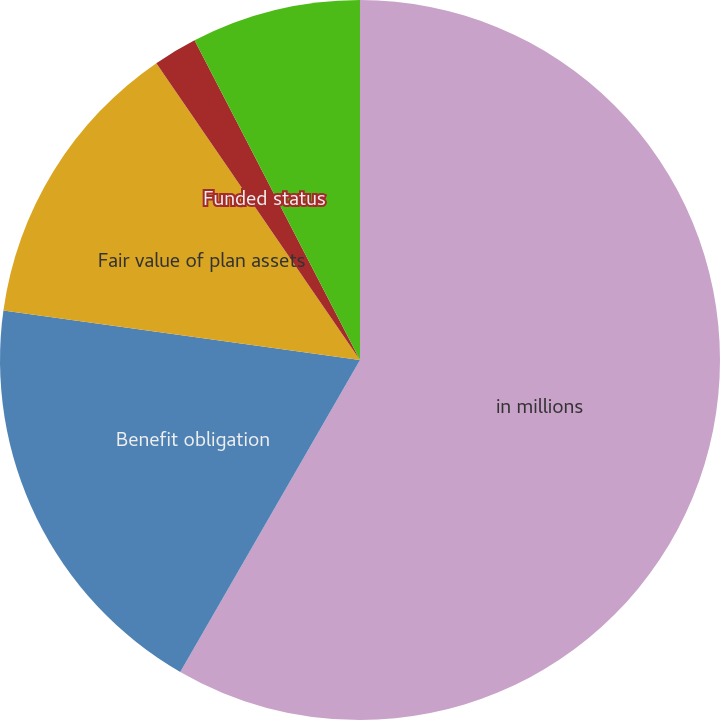Convert chart. <chart><loc_0><loc_0><loc_500><loc_500><pie_chart><fcel>in millions<fcel>Benefit obligation<fcel>Fair value of plan assets<fcel>Funded status<fcel>Accrued compensation and<nl><fcel>58.32%<fcel>18.87%<fcel>13.24%<fcel>1.97%<fcel>7.6%<nl></chart> 